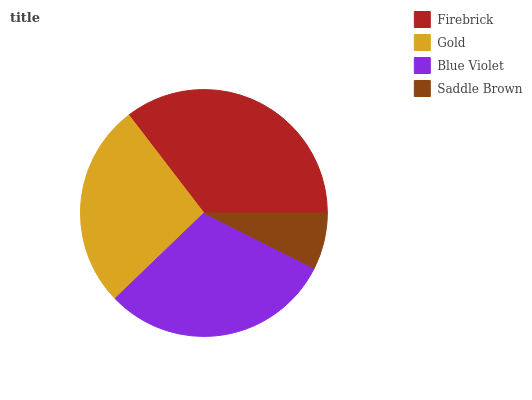Is Saddle Brown the minimum?
Answer yes or no. Yes. Is Firebrick the maximum?
Answer yes or no. Yes. Is Gold the minimum?
Answer yes or no. No. Is Gold the maximum?
Answer yes or no. No. Is Firebrick greater than Gold?
Answer yes or no. Yes. Is Gold less than Firebrick?
Answer yes or no. Yes. Is Gold greater than Firebrick?
Answer yes or no. No. Is Firebrick less than Gold?
Answer yes or no. No. Is Blue Violet the high median?
Answer yes or no. Yes. Is Gold the low median?
Answer yes or no. Yes. Is Gold the high median?
Answer yes or no. No. Is Blue Violet the low median?
Answer yes or no. No. 